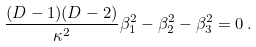<formula> <loc_0><loc_0><loc_500><loc_500>\frac { ( D - 1 ) ( D - 2 ) } { \kappa ^ { 2 } } \beta _ { 1 } ^ { 2 } - \beta _ { 2 } ^ { 2 } - \beta _ { 3 } ^ { 2 } = 0 \, .</formula> 